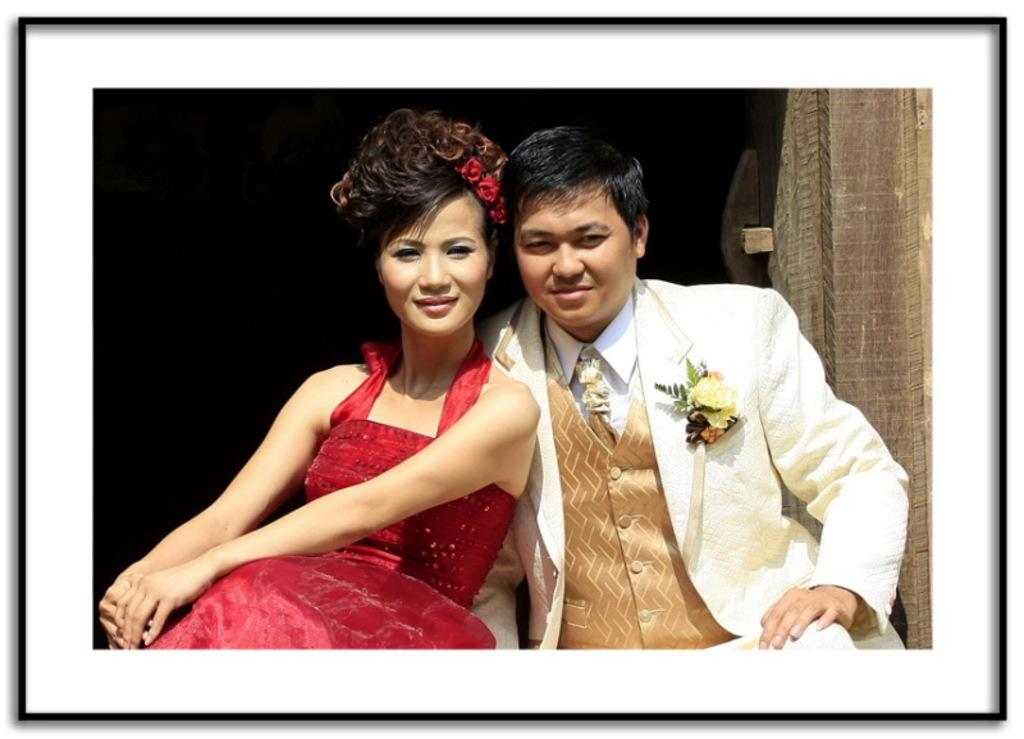What is the lady in the image wearing? The lady in the image is wearing a red dress. What is the man in the image wearing? The man in the image is wearing a white suit. What can be seen on the right side of the image? There is a wooden object on the right side of the image. What feature is present around the edges of the image? The image has borders. How many bricks are used to build the transport vehicle in the image? There is no transport vehicle or bricks present in the image. What is the afterthought of the lady in the red dress? The image does not provide any information about the lady's thoughts or intentions, so it is impossible to determine her afterthought. 